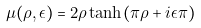Convert formula to latex. <formula><loc_0><loc_0><loc_500><loc_500>\mu ( \rho , \epsilon ) = 2 \rho \tanh ( \pi \rho + i \epsilon \pi )</formula> 